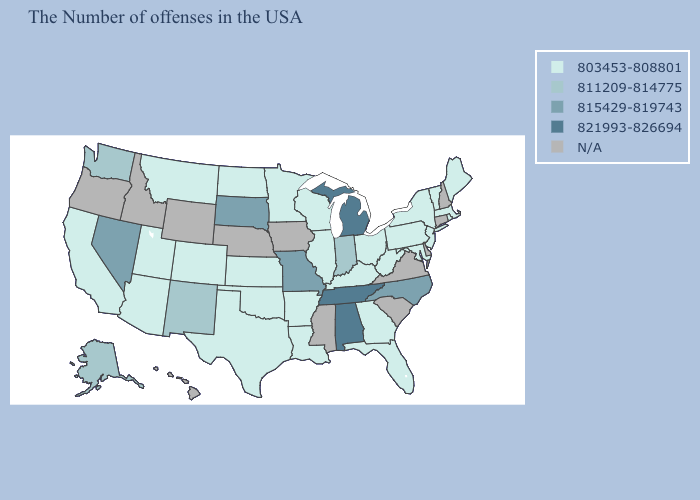What is the lowest value in the USA?
Answer briefly. 803453-808801. Does Maryland have the lowest value in the South?
Give a very brief answer. Yes. What is the value of Nebraska?
Keep it brief. N/A. Does the first symbol in the legend represent the smallest category?
Keep it brief. Yes. Is the legend a continuous bar?
Concise answer only. No. What is the value of Florida?
Short answer required. 803453-808801. What is the value of Missouri?
Concise answer only. 815429-819743. Does Alabama have the lowest value in the USA?
Be succinct. No. Does the map have missing data?
Answer briefly. Yes. Which states have the lowest value in the South?
Quick response, please. Maryland, West Virginia, Florida, Georgia, Kentucky, Louisiana, Arkansas, Oklahoma, Texas. What is the highest value in the USA?
Answer briefly. 821993-826694. Does Illinois have the lowest value in the MidWest?
Keep it brief. Yes. What is the value of Kansas?
Be succinct. 803453-808801. 